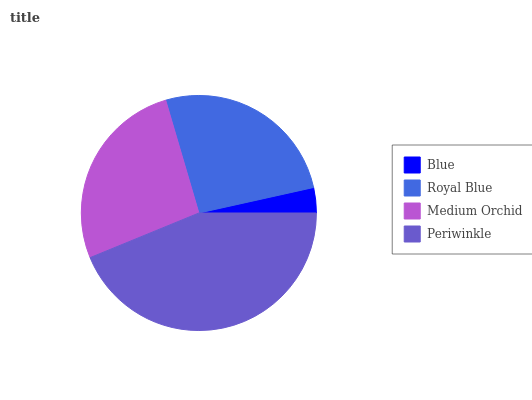Is Blue the minimum?
Answer yes or no. Yes. Is Periwinkle the maximum?
Answer yes or no. Yes. Is Royal Blue the minimum?
Answer yes or no. No. Is Royal Blue the maximum?
Answer yes or no. No. Is Royal Blue greater than Blue?
Answer yes or no. Yes. Is Blue less than Royal Blue?
Answer yes or no. Yes. Is Blue greater than Royal Blue?
Answer yes or no. No. Is Royal Blue less than Blue?
Answer yes or no. No. Is Medium Orchid the high median?
Answer yes or no. Yes. Is Royal Blue the low median?
Answer yes or no. Yes. Is Royal Blue the high median?
Answer yes or no. No. Is Medium Orchid the low median?
Answer yes or no. No. 